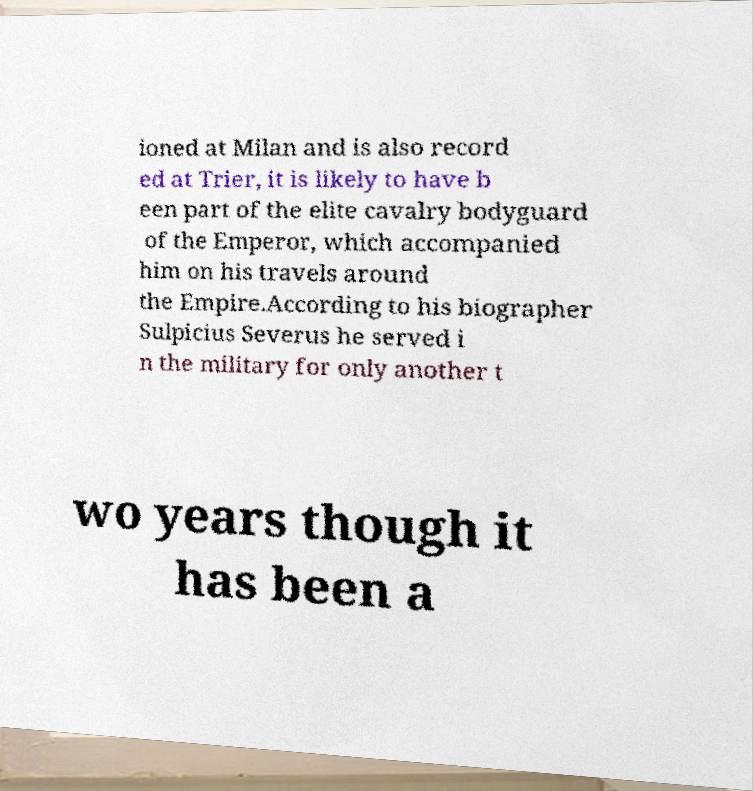I need the written content from this picture converted into text. Can you do that? ioned at Milan and is also record ed at Trier, it is likely to have b een part of the elite cavalry bodyguard of the Emperor, which accompanied him on his travels around the Empire.According to his biographer Sulpicius Severus he served i n the military for only another t wo years though it has been a 